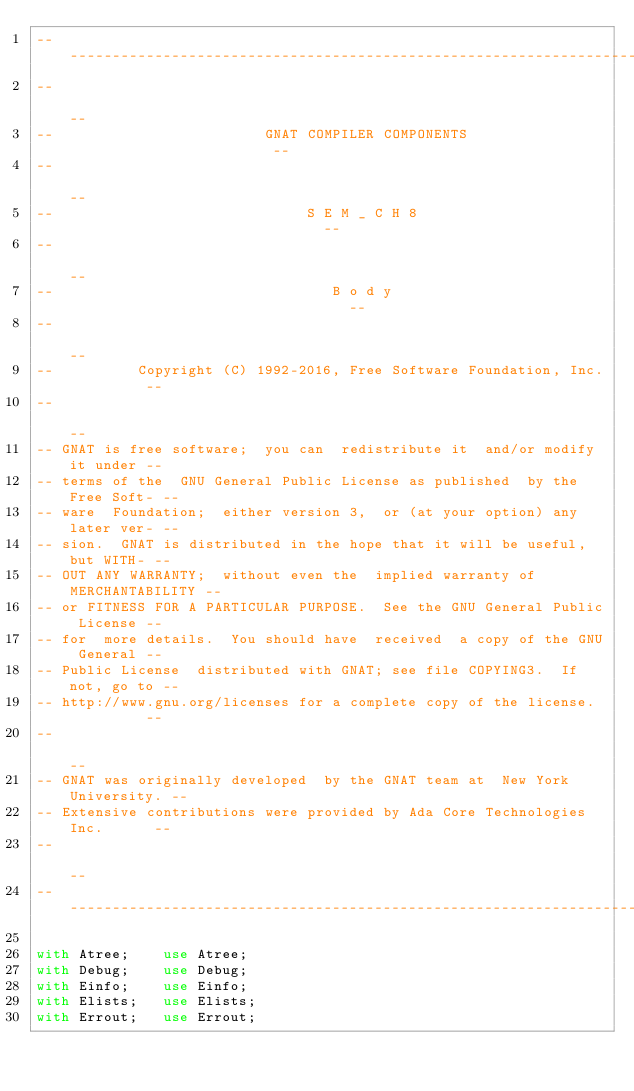Convert code to text. <code><loc_0><loc_0><loc_500><loc_500><_Ada_>------------------------------------------------------------------------------
--                                                                          --
--                         GNAT COMPILER COMPONENTS                         --
--                                                                          --
--                              S E M _ C H 8                               --
--                                                                          --
--                                 B o d y                                  --
--                                                                          --
--          Copyright (C) 1992-2016, Free Software Foundation, Inc.         --
--                                                                          --
-- GNAT is free software;  you can  redistribute it  and/or modify it under --
-- terms of the  GNU General Public License as published  by the Free Soft- --
-- ware  Foundation;  either version 3,  or (at your option) any later ver- --
-- sion.  GNAT is distributed in the hope that it will be useful, but WITH- --
-- OUT ANY WARRANTY;  without even the  implied warranty of MERCHANTABILITY --
-- or FITNESS FOR A PARTICULAR PURPOSE.  See the GNU General Public License --
-- for  more details.  You should have  received  a copy of the GNU General --
-- Public License  distributed with GNAT; see file COPYING3.  If not, go to --
-- http://www.gnu.org/licenses for a complete copy of the license.          --
--                                                                          --
-- GNAT was originally developed  by the GNAT team at  New York University. --
-- Extensive contributions were provided by Ada Core Technologies Inc.      --
--                                                                          --
------------------------------------------------------------------------------

with Atree;    use Atree;
with Debug;    use Debug;
with Einfo;    use Einfo;
with Elists;   use Elists;
with Errout;   use Errout;</code> 